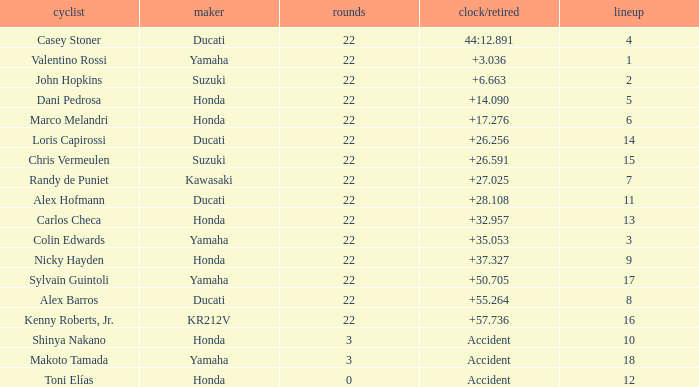What is the average grid for competitors who had more than 22 laps and time/retired of +17.276? None. 